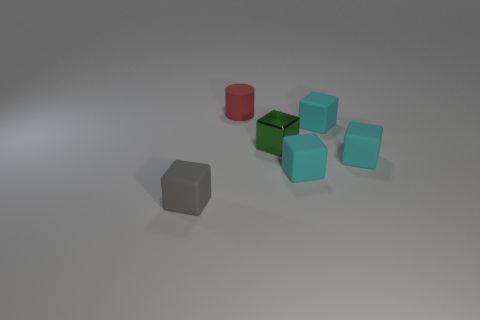What shape is the gray thing that is the same size as the green cube?
Your answer should be very brief. Cube. What shape is the cyan thing that is behind the tiny object that is to the right of the tiny rubber cube behind the metallic block?
Provide a succinct answer. Cube. Is the number of small things that are right of the green object the same as the number of metallic cubes?
Your response must be concise. No. Do the red matte object and the shiny object have the same size?
Make the answer very short. Yes. What number of metal things are either large cyan blocks or green cubes?
Keep it short and to the point. 1. There is a gray object that is the same size as the green shiny block; what is it made of?
Provide a short and direct response. Rubber. What number of other objects are there of the same material as the green thing?
Provide a short and direct response. 0. Is the number of small green metallic things that are to the right of the small green metallic block less than the number of metallic blocks?
Your answer should be compact. Yes. Does the small gray matte thing have the same shape as the tiny green object?
Provide a succinct answer. Yes. How big is the cyan thing behind the cyan cube on the right side of the small cyan block behind the green object?
Provide a short and direct response. Small. 